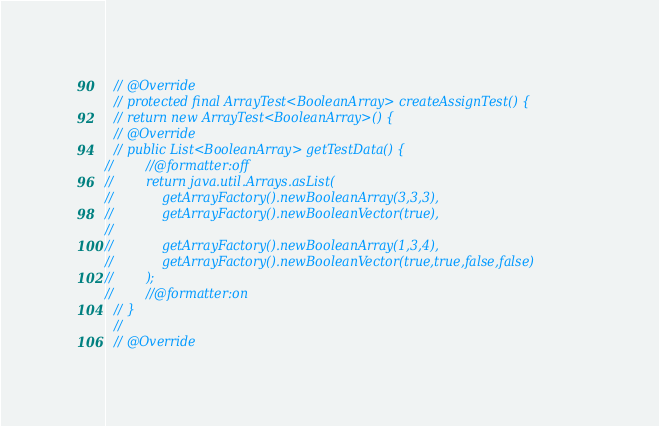<code> <loc_0><loc_0><loc_500><loc_500><_Java_>  // @Override
  // protected final ArrayTest<BooleanArray> createAssignTest() {
  // return new ArrayTest<BooleanArray>() {
  // @Override
  // public List<BooleanArray> getTestData() {
//        //@formatter:off
//        return java.util.Arrays.asList(
//            getArrayFactory().newBooleanArray(3,3,3),
//            getArrayFactory().newBooleanVector(true),
//
//            getArrayFactory().newBooleanArray(1,3,4),
//            getArrayFactory().newBooleanVector(true,true,false,false)
//        );
//        //@formatter:on
  // }
  //
  // @Override</code> 